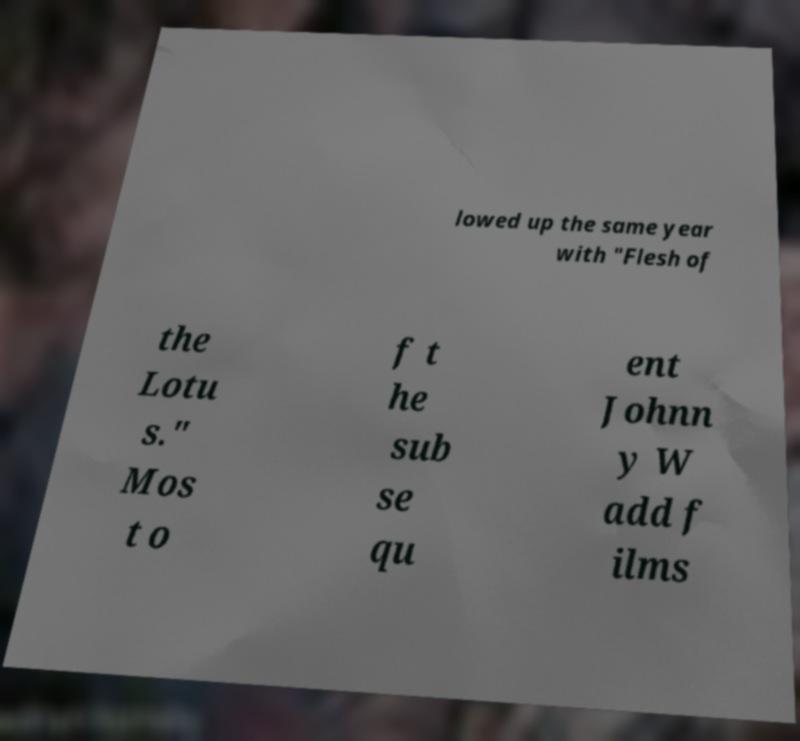For documentation purposes, I need the text within this image transcribed. Could you provide that? lowed up the same year with "Flesh of the Lotu s." Mos t o f t he sub se qu ent Johnn y W add f ilms 